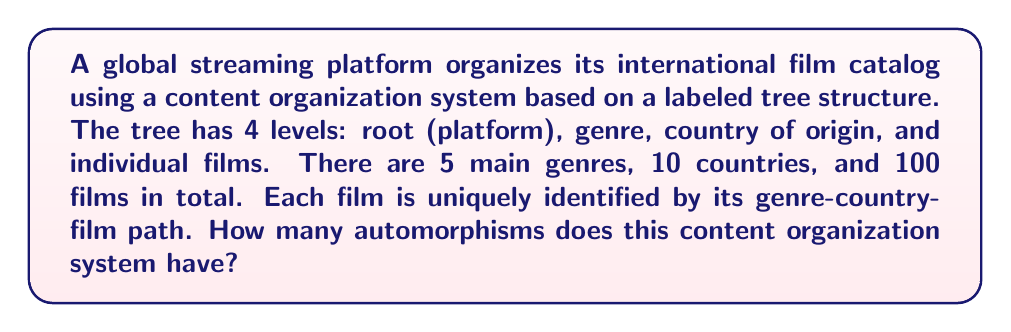Could you help me with this problem? To solve this problem, we need to consider the structure of the tree and the constraints on how elements can be rearranged:

1) The root (platform) level is fixed and has only one node.

2) The genre level has 5 nodes, which can be permuted in any way. This gives us 5! permutations.

3) For each genre, we have 10 country nodes. These can be permuted independently for each genre. This gives us (10!)^5 permutations.

4) The films are uniquely identified by their full path, so they cannot be permuted within their genre-country group.

The total number of automorphisms is the product of the number of permutations at each level:

$$ |\text{Aut}(G)| = 1 \cdot 5! \cdot (10!)^5 $$

Let's calculate this:

$$ |\text{Aut}(G)| = 1 \cdot 120 \cdot (3,628,800)^5 $$

$$ = 120 \cdot 3,628,800^5 $$

$$ = 120 \cdot 2.55\times10^{38} $$

$$ = 3.06\times10^{40} $$

This large number reflects the many ways the content can be reorganized while maintaining the overall structure and uniqueness of each film's path.
Answer: The content organization system has approximately $3.06\times10^{40}$ automorphisms. 